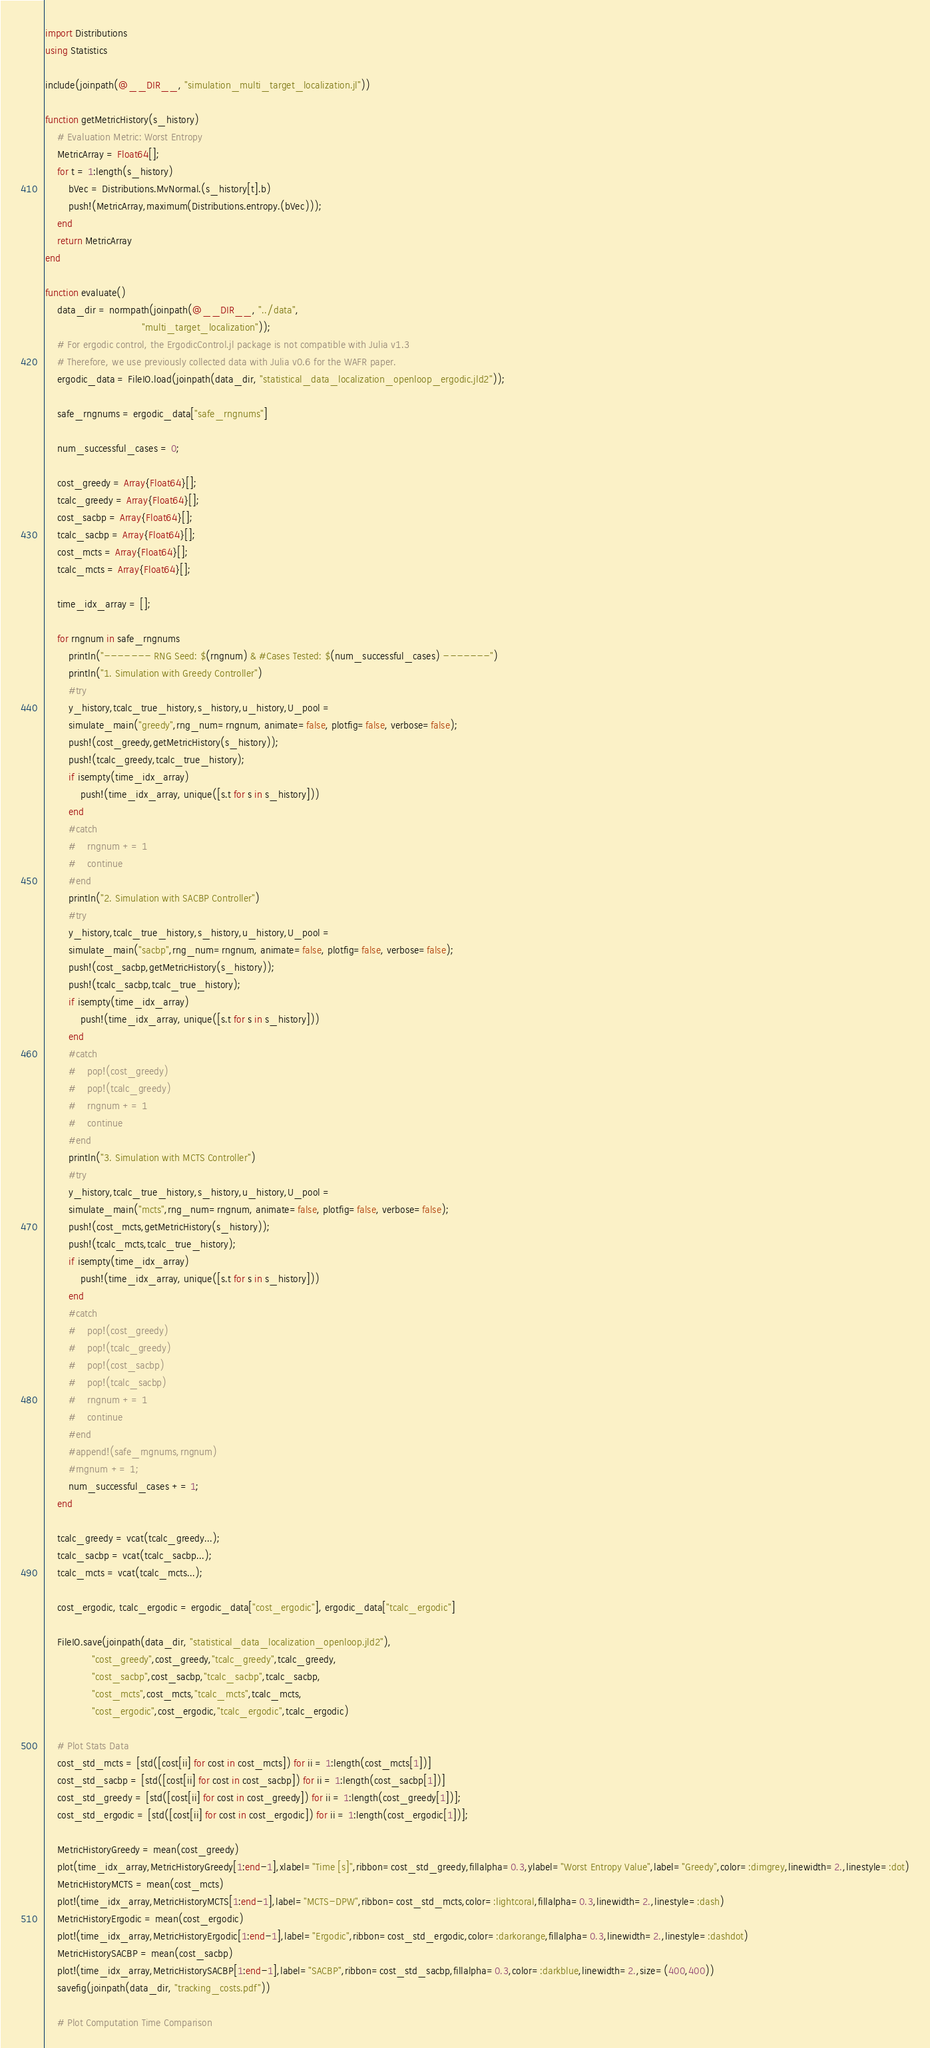<code> <loc_0><loc_0><loc_500><loc_500><_Julia_>import Distributions
using Statistics

include(joinpath(@__DIR__, "simulation_multi_target_localization.jl"))

function getMetricHistory(s_history)
    # Evaluation Metric: Worst Entropy
    MetricArray = Float64[];
    for t = 1:length(s_history)
        bVec = Distributions.MvNormal.(s_history[t].b)
        push!(MetricArray,maximum(Distributions.entropy.(bVec)));
    end
    return MetricArray
end

function evaluate()
    data_dir = normpath(joinpath(@__DIR__, "../data",
                                 "multi_target_localization"));
    # For ergodic control, the ErgodicControl.jl package is not compatible with Julia v1.3
    # Therefore, we use previously collected data with Julia v0.6 for the WAFR paper.
    ergodic_data = FileIO.load(joinpath(data_dir, "statistical_data_localization_openloop_ergodic.jld2"));

    safe_rngnums = ergodic_data["safe_rngnums"]

    num_successful_cases = 0;

    cost_greedy = Array{Float64}[];
    tcalc_greedy = Array{Float64}[];
    cost_sacbp = Array{Float64}[];
    tcalc_sacbp = Array{Float64}[];
    cost_mcts = Array{Float64}[];
    tcalc_mcts = Array{Float64}[];

    time_idx_array = [];

    for rngnum in safe_rngnums
        println("------- RNG Seed: $(rngnum) & #Cases Tested: $(num_successful_cases) -------")
        println("1. Simulation with Greedy Controller")
        #try
        y_history,tcalc_true_history,s_history,u_history,U_pool =
        simulate_main("greedy",rng_num=rngnum, animate=false, plotfig=false, verbose=false);
        push!(cost_greedy,getMetricHistory(s_history));
        push!(tcalc_greedy,tcalc_true_history);
        if isempty(time_idx_array)
            push!(time_idx_array, unique([s.t for s in s_history]))
        end
        #catch
        #    rngnum += 1
        #    continue
        #end
        println("2. Simulation with SACBP Controller")
        #try
        y_history,tcalc_true_history,s_history,u_history,U_pool =
        simulate_main("sacbp",rng_num=rngnum, animate=false, plotfig=false, verbose=false);
        push!(cost_sacbp,getMetricHistory(s_history));
        push!(tcalc_sacbp,tcalc_true_history);
        if isempty(time_idx_array)
            push!(time_idx_array, unique([s.t for s in s_history]))
        end
        #catch
        #    pop!(cost_greedy)
        #    pop!(tcalc_greedy)
        #    rngnum += 1
        #    continue
        #end
        println("3. Simulation with MCTS Controller")
        #try
        y_history,tcalc_true_history,s_history,u_history,U_pool =
        simulate_main("mcts",rng_num=rngnum, animate=false, plotfig=false, verbose=false);
        push!(cost_mcts,getMetricHistory(s_history));
        push!(tcalc_mcts,tcalc_true_history);
        if isempty(time_idx_array)
            push!(time_idx_array, unique([s.t for s in s_history]))
        end
        #catch
        #    pop!(cost_greedy)
        #    pop!(tcalc_greedy)
        #    pop!(cost_sacbp)
        #    pop!(tcalc_sacbp)
        #    rngnum += 1
        #    continue
        #end
        #append!(safe_rngnums,rngnum)
        #rngnum += 1;
        num_successful_cases += 1;
    end

    tcalc_greedy = vcat(tcalc_greedy...);
    tcalc_sacbp = vcat(tcalc_sacbp...);
    tcalc_mcts = vcat(tcalc_mcts...);

    cost_ergodic, tcalc_ergodic = ergodic_data["cost_ergodic"], ergodic_data["tcalc_ergodic"]

    FileIO.save(joinpath(data_dir, "statistical_data_localization_openloop.jld2"),
                "cost_greedy",cost_greedy,"tcalc_greedy",tcalc_greedy,
                "cost_sacbp",cost_sacbp,"tcalc_sacbp",tcalc_sacbp,
                "cost_mcts",cost_mcts,"tcalc_mcts",tcalc_mcts,
                "cost_ergodic",cost_ergodic,"tcalc_ergodic",tcalc_ergodic)

    # Plot Stats Data
    cost_std_mcts = [std([cost[ii] for cost in cost_mcts]) for ii = 1:length(cost_mcts[1])]
    cost_std_sacbp = [std([cost[ii] for cost in cost_sacbp]) for ii = 1:length(cost_sacbp[1])]
    cost_std_greedy = [std([cost[ii] for cost in cost_greedy]) for ii = 1:length(cost_greedy[1])];
    cost_std_ergodic = [std([cost[ii] for cost in cost_ergodic]) for ii = 1:length(cost_ergodic[1])];

    MetricHistoryGreedy = mean(cost_greedy)
    plot(time_idx_array,MetricHistoryGreedy[1:end-1],xlabel="Time [s]",ribbon=cost_std_greedy,fillalpha=0.3,ylabel="Worst Entropy Value",label="Greedy",color=:dimgrey,linewidth=2.,linestyle=:dot)
    MetricHistoryMCTS = mean(cost_mcts)
    plot!(time_idx_array,MetricHistoryMCTS[1:end-1],label="MCTS-DPW",ribbon=cost_std_mcts,color=:lightcoral,fillalpha=0.3,linewidth=2.,linestyle=:dash)
    MetricHistoryErgodic = mean(cost_ergodic)
    plot!(time_idx_array,MetricHistoryErgodic[1:end-1],label="Ergodic",ribbon=cost_std_ergodic,color=:darkorange,fillalpha=0.3,linewidth=2.,linestyle=:dashdot)
    MetricHistorySACBP = mean(cost_sacbp)
    plot!(time_idx_array,MetricHistorySACBP[1:end-1],label="SACBP",ribbon=cost_std_sacbp,fillalpha=0.3,color=:darkblue,linewidth=2.,size=(400,400))
    savefig(joinpath(data_dir, "tracking_costs.pdf"))

    # Plot Computation Time Comparison</code> 